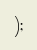<code> <loc_0><loc_0><loc_500><loc_500><_TypeScript_>);
</code> 